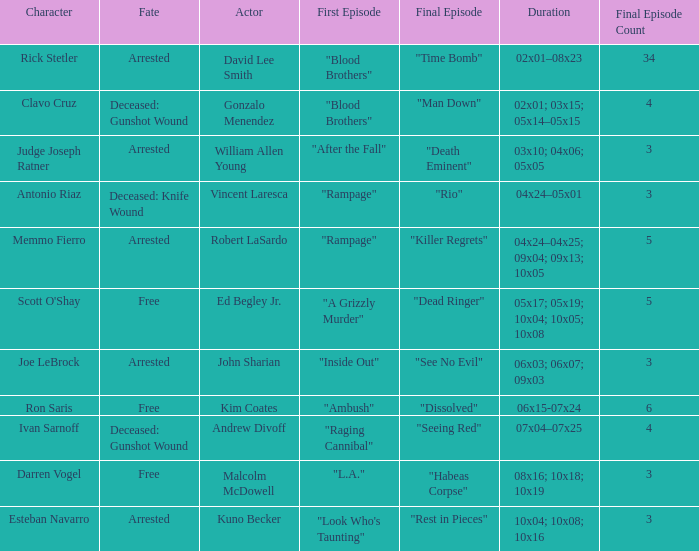What's the total number of final epbeingode count with character being rick stetler 1.0. 